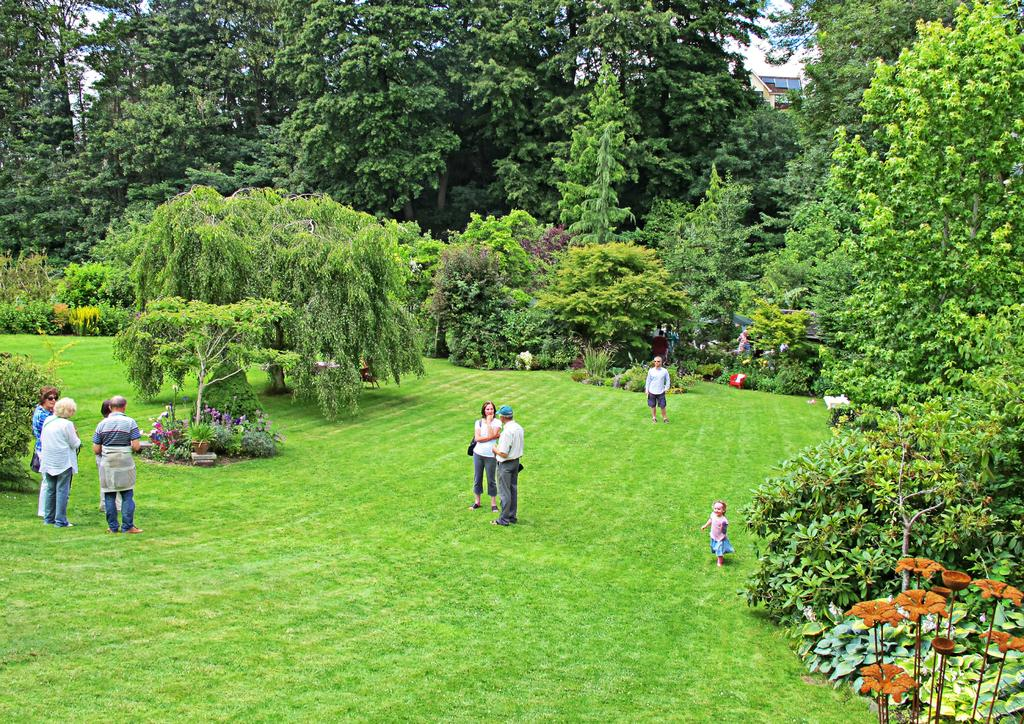What can be seen in the image? There are people standing in the image. Where are the people standing? The people are standing on the ground. What can be seen in the background of the image? There are trees, plants, and a building in the background of the image. What type of pencil is being used by the people in the image? There is no pencil present in the image; the people are simply standing. 